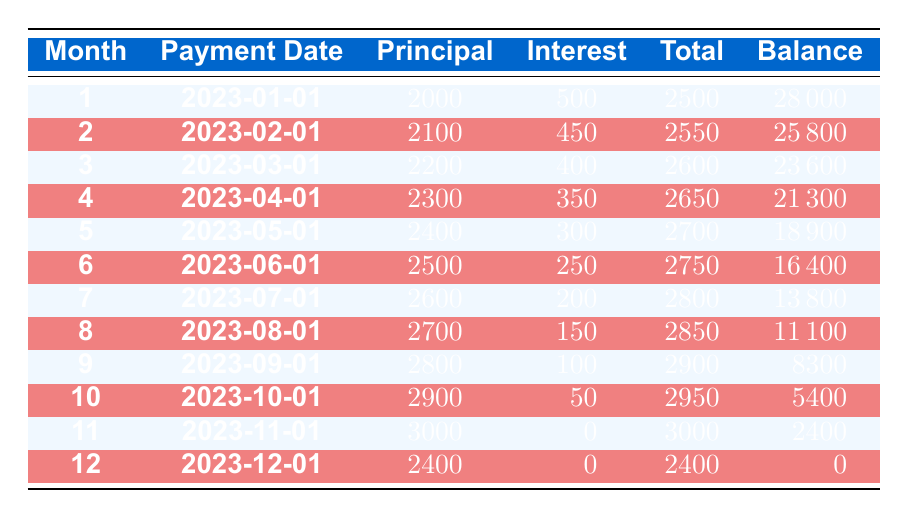What was the total payment made in the first month? In the first month, the total payment is listed in the corresponding row under the "Total" column, which shows 2500.
Answer: 2500 What was the interest payment in the tenth month? The interest payment for the tenth month can be found in the tenth row under the "Interest" column, which is 50.
Answer: 50 What is the remaining balance after the fifth month? The remaining balance after the fifth month is noted in the fifth row's "Balance" column, which indicates 18900.
Answer: 18900 How much did the principal payment increase from the first month to the third month? In the first month, the principal payment was 2000, and in the third month, it was 2200. To find the increase, subtract the first month from the third month: 2200 - 2000 = 200.
Answer: 200 What was the average total payment over the entire lease term? The total payments for all months are added together: 2500 + 2550 + 2600 + 2650 + 2700 + 2750 + 2800 + 2850 + 2900 + 2950 + 3000 + 2400 = 31200. There are 12 months, so the average is 31200 / 12 = 2600.
Answer: 2600 Did any month have an interest payment of zero? By examining the interest payments in the table, it shows that in months 11 and 12, the interest payment is listed as 0. Therefore, the answer is yes.
Answer: Yes What is the total amount of principal payments made from months 1 to 6? The principal payments from months 1 to 6 are: 2000 + 2100 + 2200 + 2300 + 2400 + 2500 = 13600. This total is calculated by simply adding these values together.
Answer: 13600 How much did the total payments decrease from the first month to the last month? The total payment in the first month was 2500, and in the last month (twelfth month) it was 2400. The decrease is calculated as 2500 - 2400 = 100.
Answer: 100 What was the total remaining balance after 9 months? The remaining balance after 9 months can be found in the 9th row of the "Balance" column, which indicates 8300.
Answer: 8300 